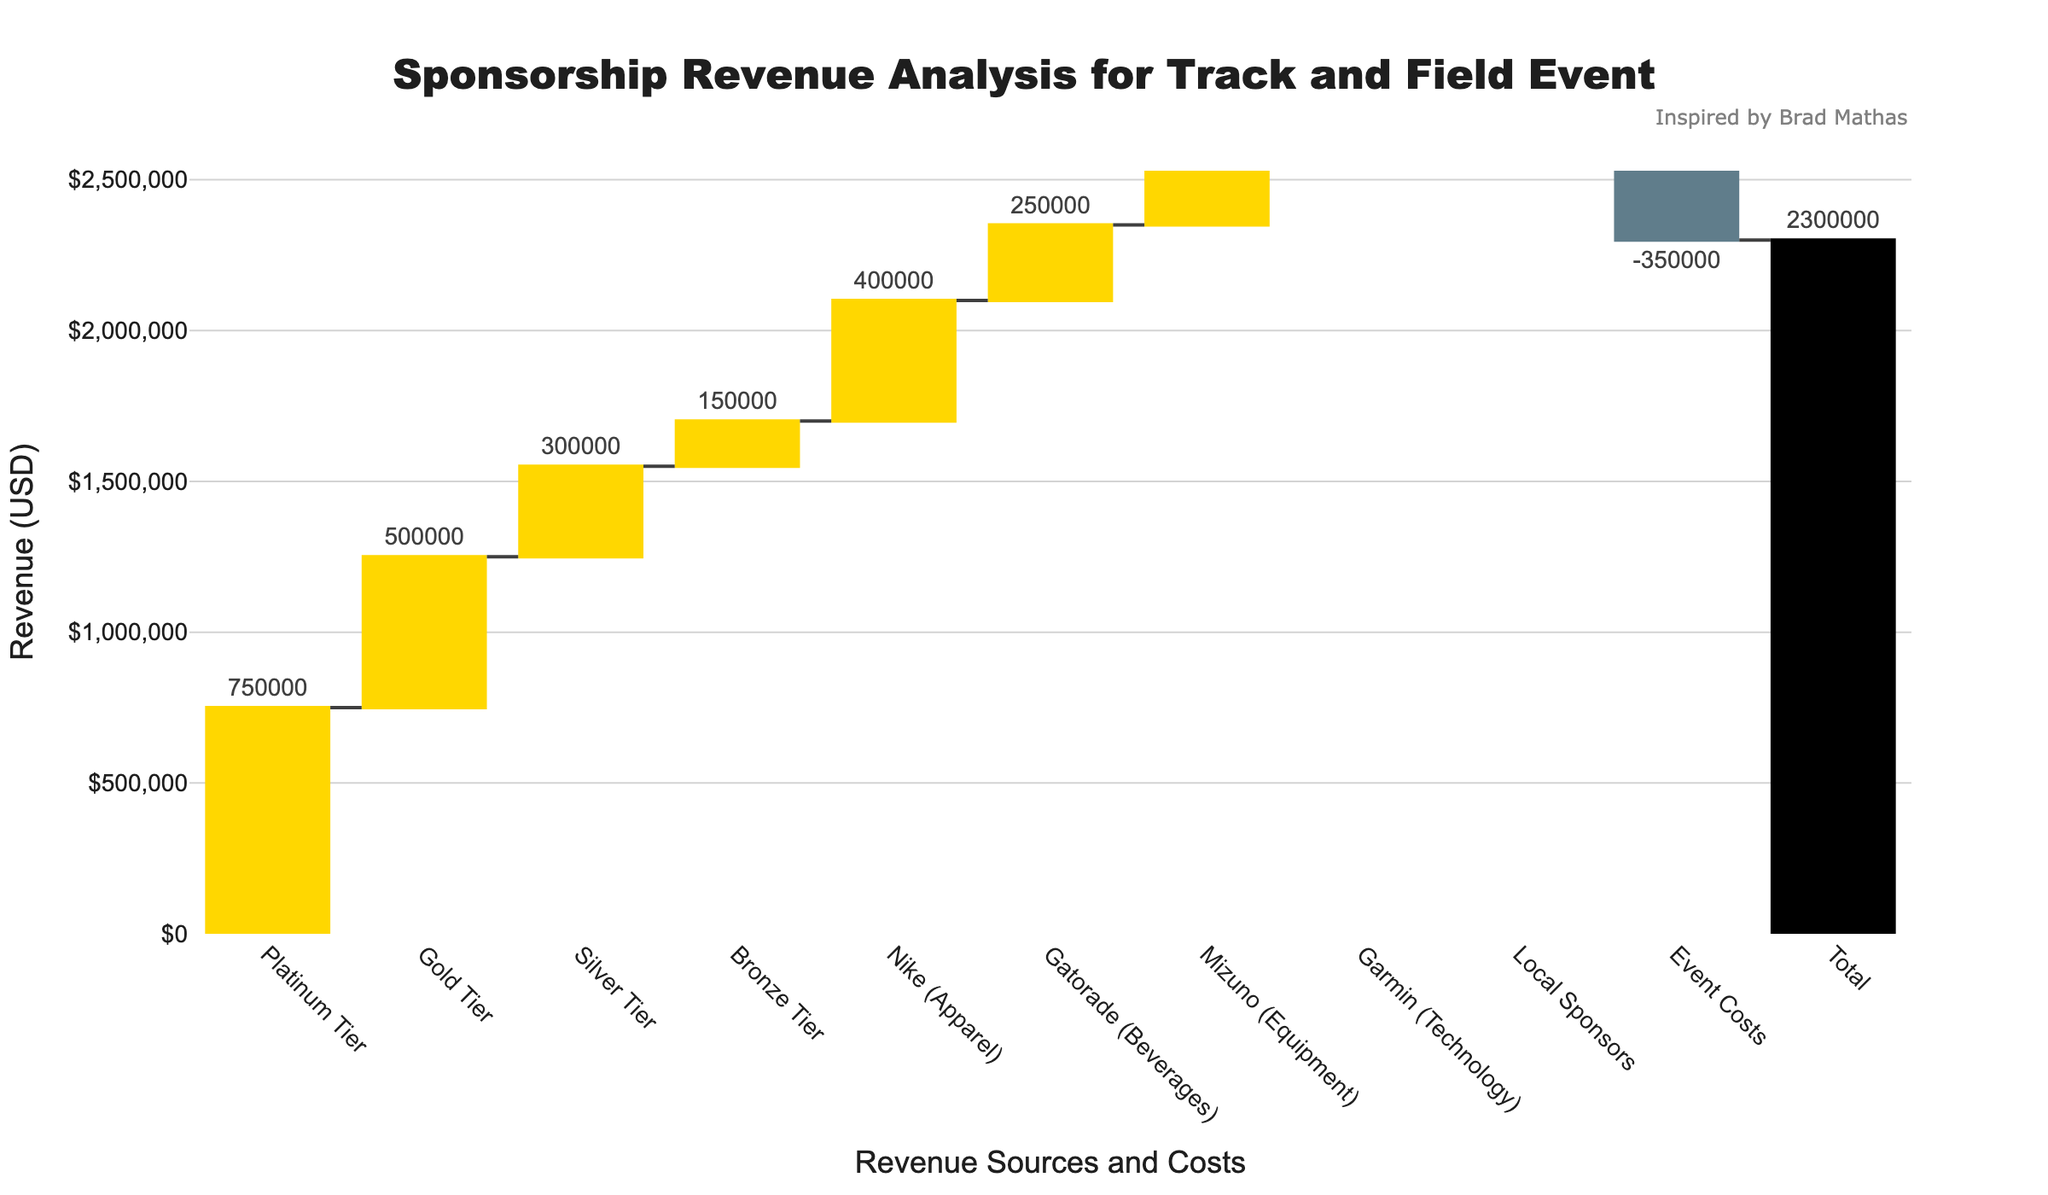What is the total sponsorship revenue shown in the chart? The chart displays the total sponsorship revenue at the bottom. The value labeled "Total" is $2,300,000.
Answer: $2,300,000 Which sponsor tier contributes the most to the revenue? By observing the heights of the bars, the Platinum Tier column is the tallest among the tiers, indicating it contributes the most to the revenue.
Answer: Platinum Tier What are the costs deducted from the total revenue? The negative bars represent costs. From the figure, the costs shown are "Local Sponsors" and "Event Costs".
Answer: Local Sponsors and Event Costs How does the revenue from Nike (Apparel) compare to Gatorade (Beverages)? Nike (Apparel) has a revenue of $400,000, while Gatorade (Beverages) has a revenue of $250,000. By comparing these values, Nike (Apparel) brings in more revenue than Gatorade (Beverages).
Answer: Nike (Apparel) brings in more revenue What is the combined revenue of the Bronze Tier and Garmin (Technology)? To find the combined revenue, sum up the revenues from Bronze Tier ($150,000) and Garmin (Technology) ($180,000). The sum is $150,000 + $180,000 = $330,000.
Answer: $330,000 Which brand has the lowest sponsorship revenue? Looking at the individual bars, Garmin (Technology) with $180,000 appears to be the lowest compared to Nike, Gatorade, Mizuno, and the tiers.
Answer: Garmin (Technology) By how much does the revenue from Silver Tier exceed the revenue from Mizuno (Equipment)? The revenue from Silver Tier is $300,000 and from Mizuno (Equipment) is $200,000. The difference is $300,000 - $200,000 = $100,000.
Answer: $100,000 What is the net effect of Local Sponsors and Event Costs on total revenue? Both Local Sponsors and Event Costs are negative values: -$80,000 (Local Sponsors) and -$350,000 (Event Costs). Summing these up gives -$80,000 + (-$350,000) = -$430,000.
Answer: -$430,000 